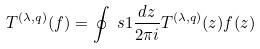<formula> <loc_0><loc_0><loc_500><loc_500>T ^ { ( \lambda , q ) } ( f ) = \oint _ { \ } s 1 \frac { d z } { 2 \pi i } T ^ { ( \lambda , q ) } ( z ) f ( z )</formula> 